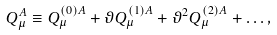Convert formula to latex. <formula><loc_0><loc_0><loc_500><loc_500>Q ^ { A } _ { \mu } \equiv Q ^ { ( 0 ) A } _ { \mu } + \vartheta Q ^ { ( 1 ) A } _ { \mu } + \vartheta ^ { 2 } Q ^ { ( 2 ) A } _ { \mu } + \dots ,</formula> 